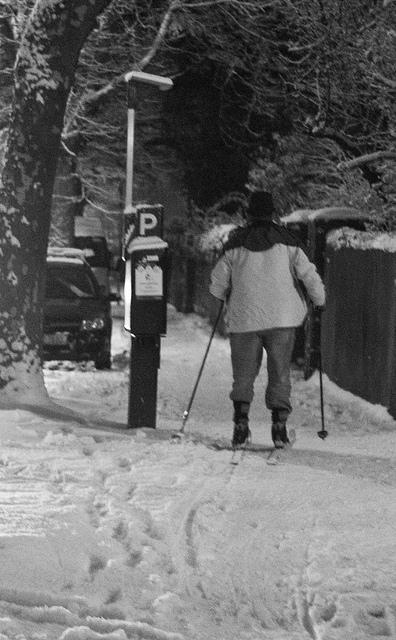What is the man holding?
Concise answer only. Ski poles. What number is on the post in the background?
Write a very short answer. P. What does this lady have on her feet?
Be succinct. Skis. What message is given to the skiers?
Write a very short answer. Parking. Is the woman the first to walk through  the snow?
Concise answer only. No. What is leaning over the sidewalk?
Keep it brief. Street light. What is causing the shadows on the snow?
Write a very short answer. Tree. 